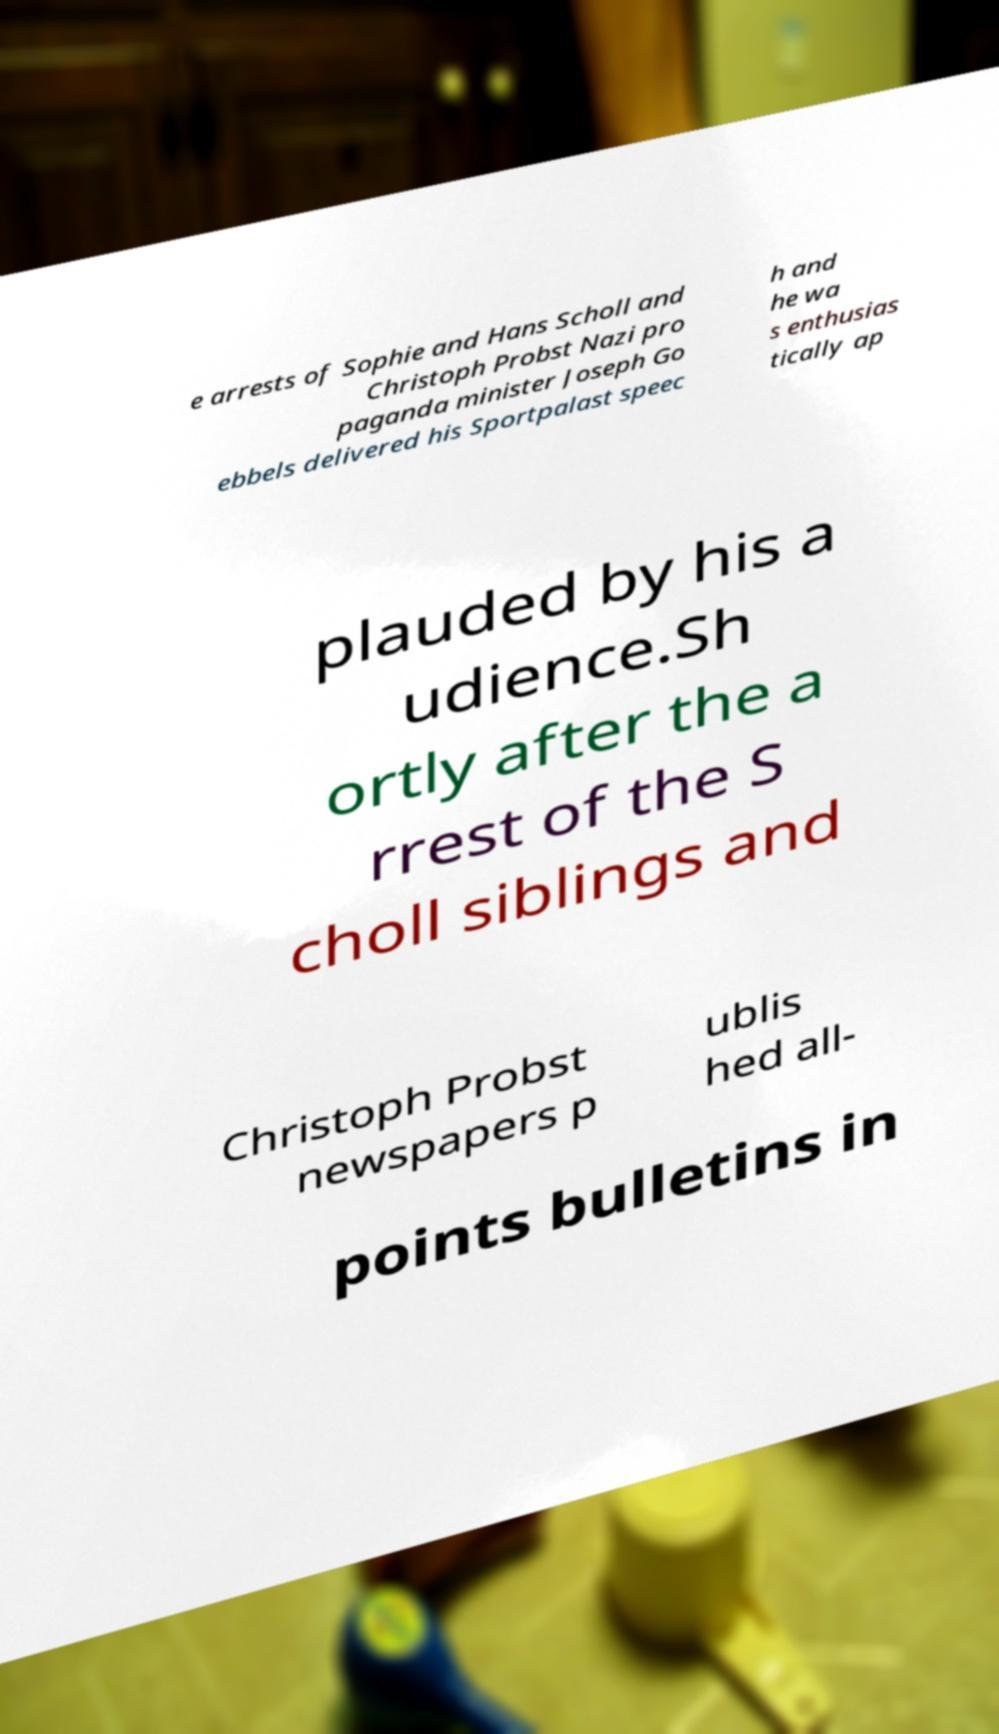What messages or text are displayed in this image? I need them in a readable, typed format. e arrests of Sophie and Hans Scholl and Christoph Probst Nazi pro paganda minister Joseph Go ebbels delivered his Sportpalast speec h and he wa s enthusias tically ap plauded by his a udience.Sh ortly after the a rrest of the S choll siblings and Christoph Probst newspapers p ublis hed all- points bulletins in 